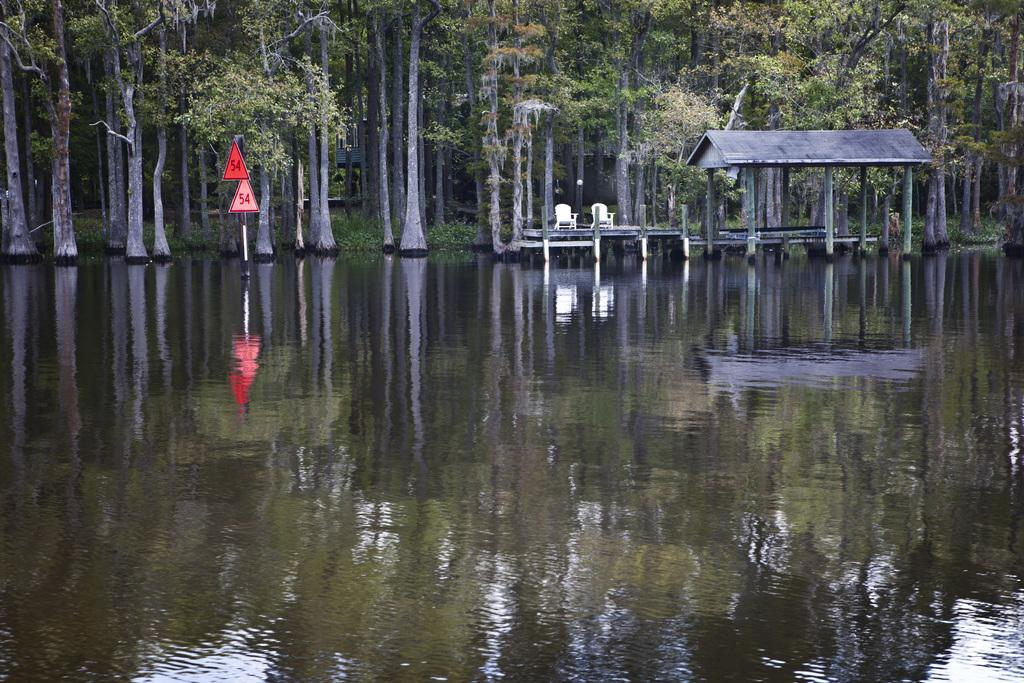What is the main element in the image? There is water in the image. What structure is on the water? There is a shed on the water. How many chairs are in the image? There are two chairs in the image. What type of vegetation is present in the image? There are many trees in the image. What objects are attached to a pole in the image? There are two red color boards attached to a pole. Can you see the sister of the person who painted the red color boards in the image? There is no person or sister mentioned in the image, only the red color boards attached to a pole. 